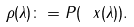<formula> <loc_0><loc_0><loc_500><loc_500>\rho ( \lambda ) \colon = P ( \ x ( \lambda ) ) .</formula> 